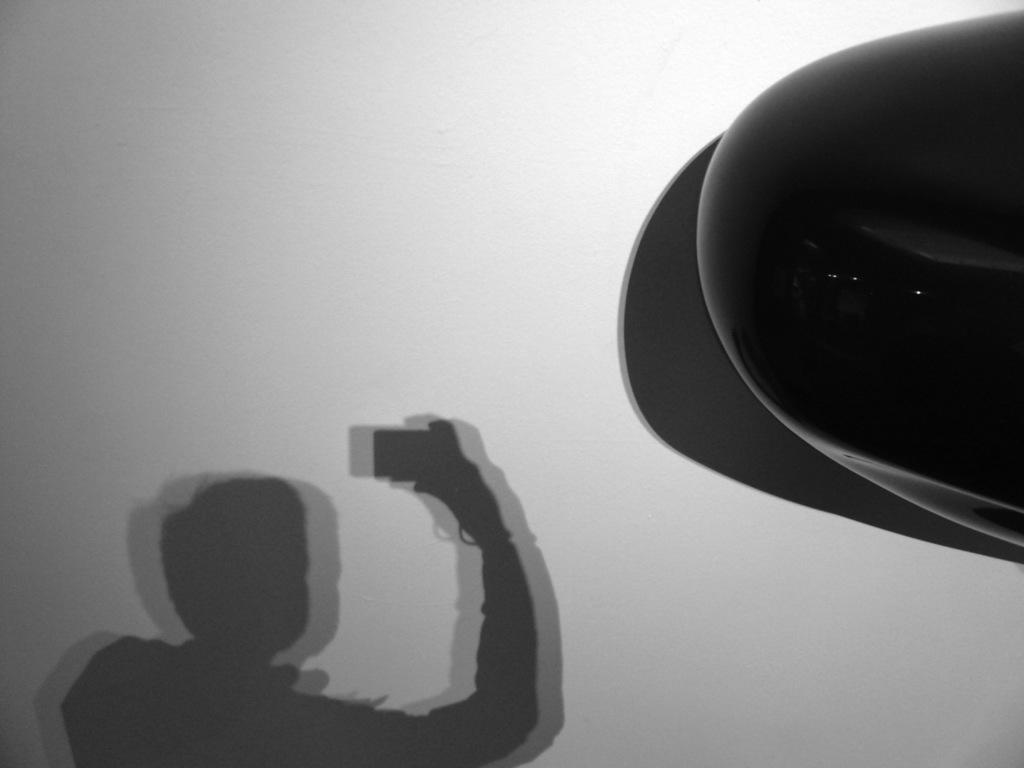What can be seen on the wall in the image? There is a shadow of a person holding an object on the wall. What color is the object in the image? The object in the image is black. Where is the park located in the image? There is no park present in the image. What type of vein can be seen in the image? There are no veins visible in the image. 